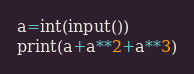Convert code to text. <code><loc_0><loc_0><loc_500><loc_500><_Python_>a=int(input())
print(a+a**2+a**3)</code> 